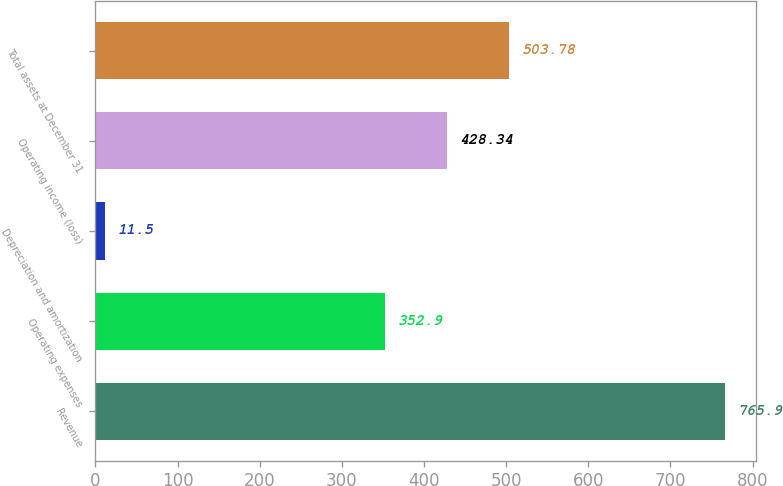<chart> <loc_0><loc_0><loc_500><loc_500><bar_chart><fcel>Revenue<fcel>Operating expenses<fcel>Depreciation and amortization<fcel>Operating income (loss)<fcel>Total assets at December 31<nl><fcel>765.9<fcel>352.9<fcel>11.5<fcel>428.34<fcel>503.78<nl></chart> 